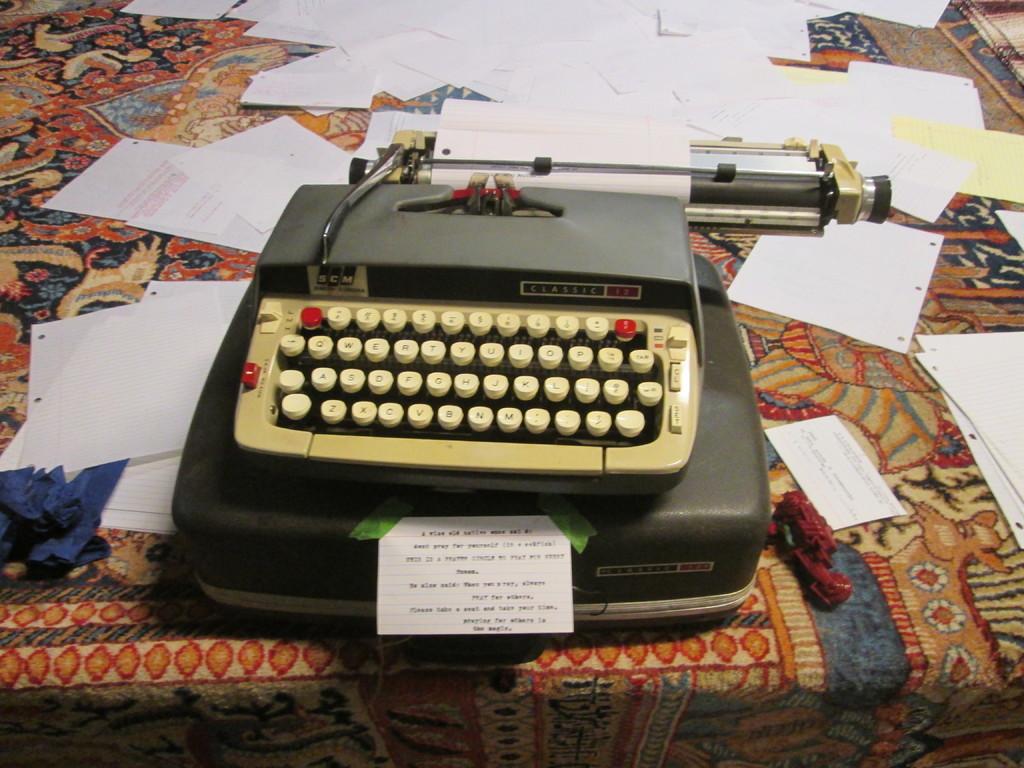What brand is this typewriter?
Give a very brief answer. Scm. 